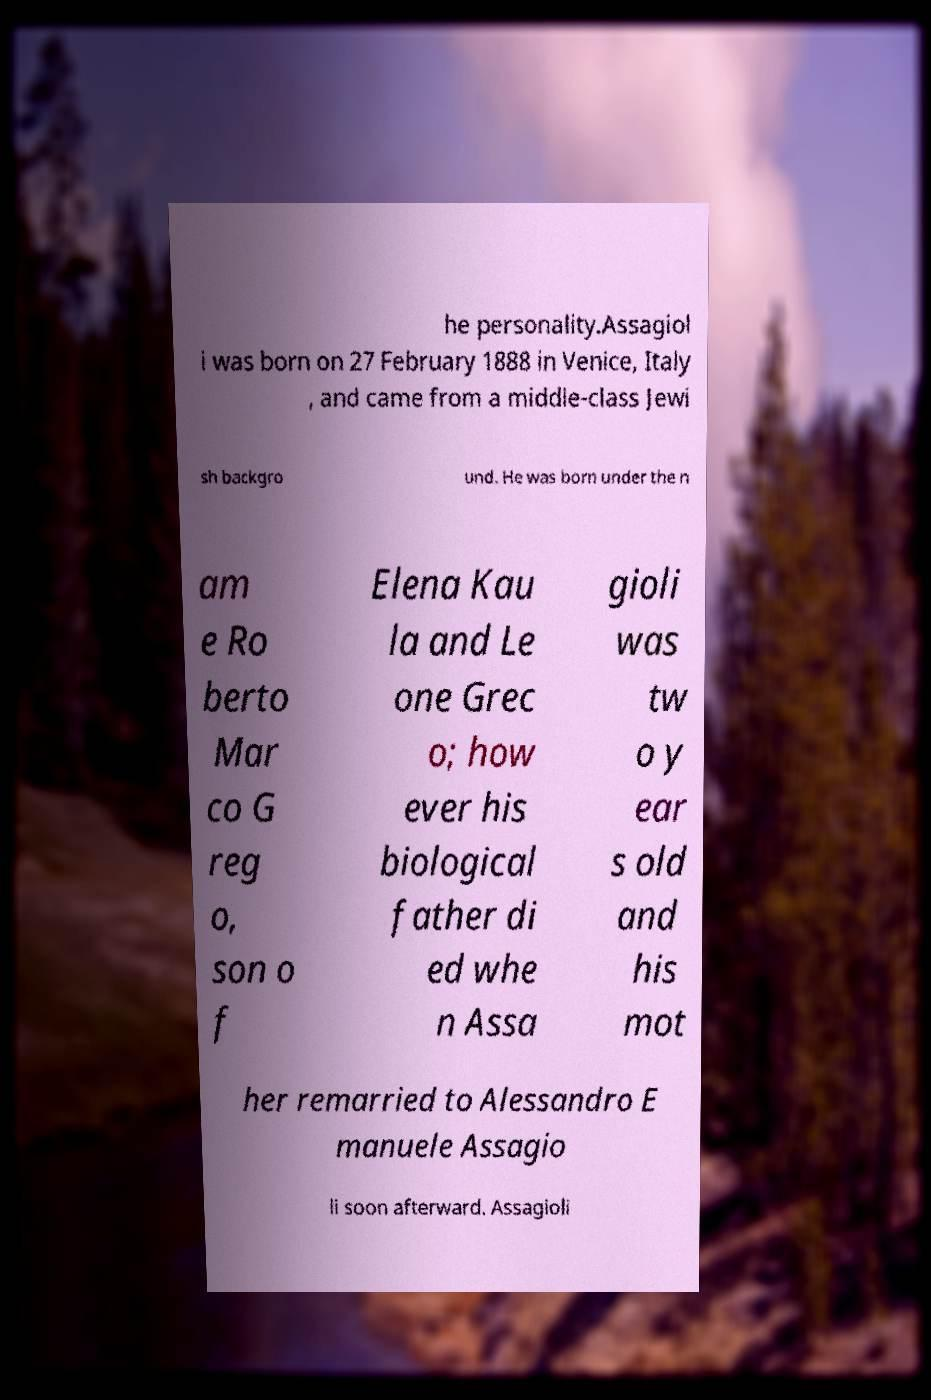Can you read and provide the text displayed in the image?This photo seems to have some interesting text. Can you extract and type it out for me? he personality.Assagiol i was born on 27 February 1888 in Venice, Italy , and came from a middle-class Jewi sh backgro und. He was born under the n am e Ro berto Mar co G reg o, son o f Elena Kau la and Le one Grec o; how ever his biological father di ed whe n Assa gioli was tw o y ear s old and his mot her remarried to Alessandro E manuele Assagio li soon afterward. Assagioli 